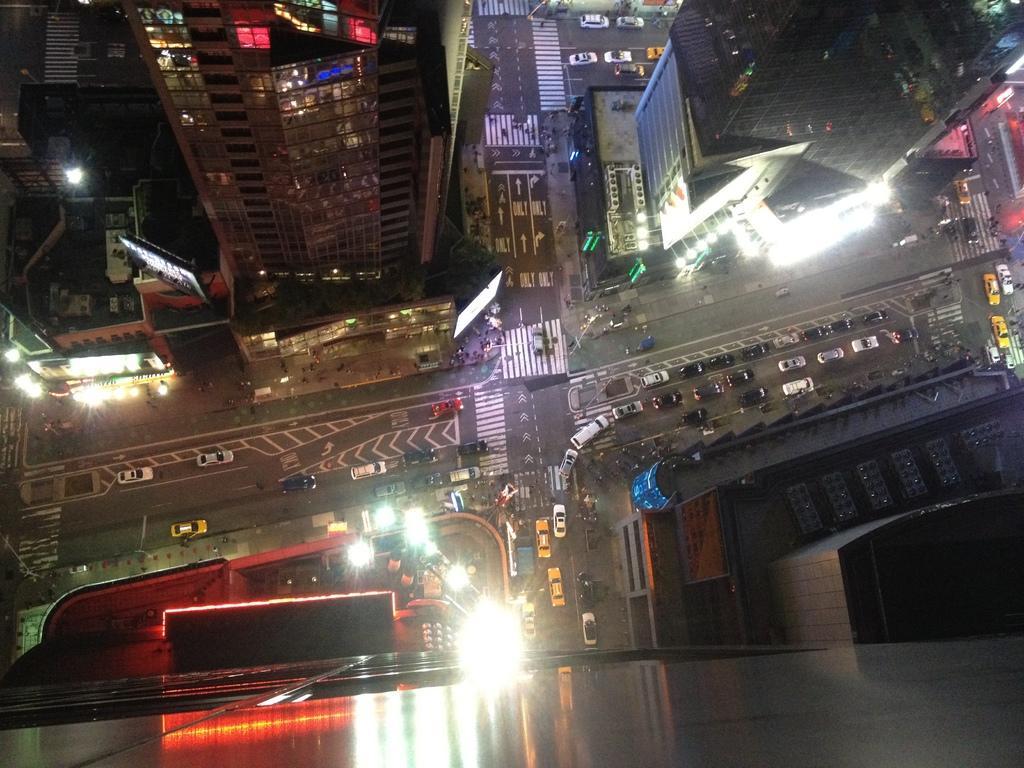How would you summarize this image in a sentence or two? In this picture we can see the skyscrapers, lights, boards, vehicles, zebra crossings on the road. This picture is taken during a night time. 